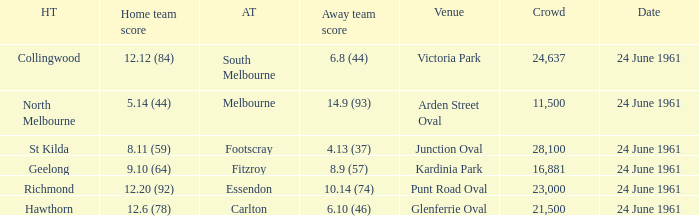Who was the home team that scored 12.6 (78)? Hawthorn. 